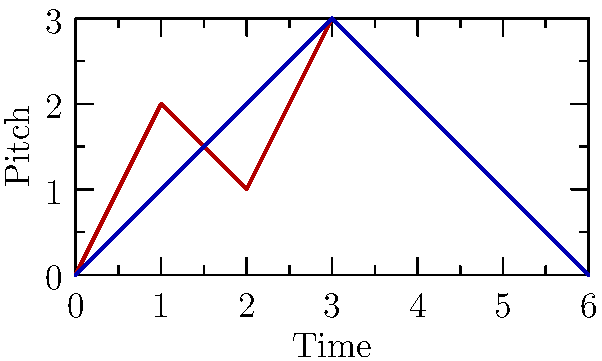Analyze the structural similarities between the Hungarian folk melody and the classical sonata form represented in the graph. Which musical concept best describes the shared characteristic evident in both melodic contours? To answer this question, let's analyze the graph step-by-step:

1. Observe the two melodic contours: the red line represents a Hungarian folk melody, and the blue line represents a classical sonata form.

2. Notice the overall shape of both contours:
   - They both start at a low point (pitch 0)
   - Rise to a peak (pitch 3) in the middle
   - Return to the starting point (pitch 0) at the end

3. This shape forms an arch-like structure, which is symmetrical around the central peak.

4. In musical terms, this arch-like structure is known as "arch form" or "symmetrical form."

5. Arch form is a common structural element in both Hungarian folk music and classical compositions, particularly those influenced by folk traditions.

6. In Hungarian folk music, this structure often reflects the natural rise and fall of melodic phrases.

7. In classical sonata form, this arch-like structure can be seen in the overall tonal plan: starting in the home key, moving to a different key area (often the dominant) in the middle, and returning to the home key at the end.

8. The shared use of this arch-like structure demonstrates a connection between folk and classical traditions, which is particularly relevant in Hungarian music due to composers like Bartók and Kodály who incorporated folk elements into their classical compositions.

Given these observations, the musical concept that best describes this shared characteristic is "arch form" or "symmetrical form."
Answer: Arch form 